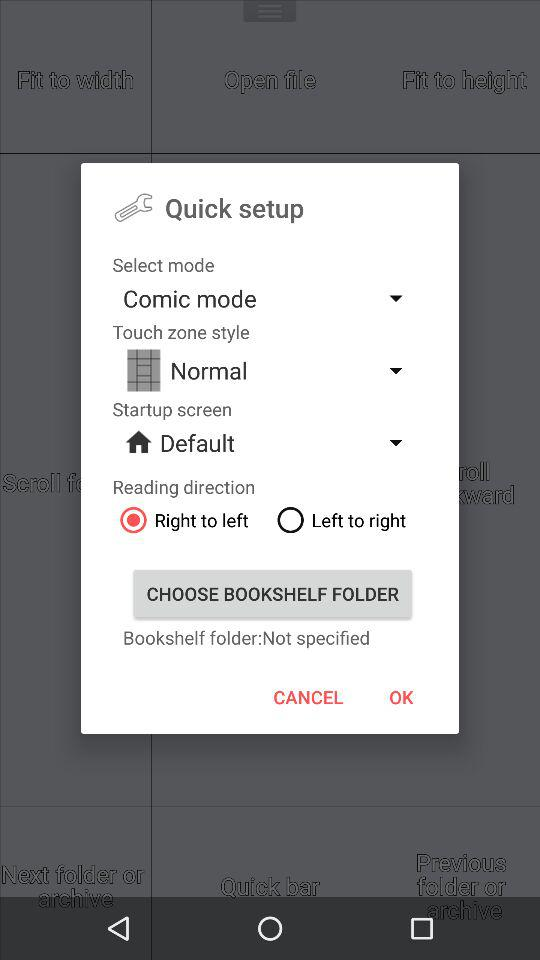Which type of "Touch zone style" is selected? The selected type of "Touch zone style" is "Normal". 